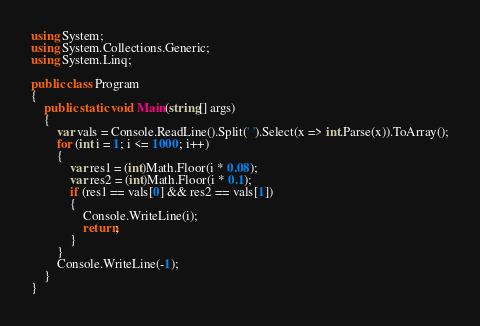Convert code to text. <code><loc_0><loc_0><loc_500><loc_500><_C#_>using System;
using System.Collections.Generic;
using System.Linq;

public class Program
{
    public static void Main(string[] args)
    {
        var vals = Console.ReadLine().Split(' ').Select(x => int.Parse(x)).ToArray();
        for (int i = 1; i <= 1000; i++)
        {
            var res1 = (int)Math.Floor(i * 0.08);
            var res2 = (int)Math.Floor(i * 0.1);
            if (res1 == vals[0] && res2 == vals[1])
            {
                Console.WriteLine(i);
                return;
            }
        }
        Console.WriteLine(-1);
    }
}</code> 